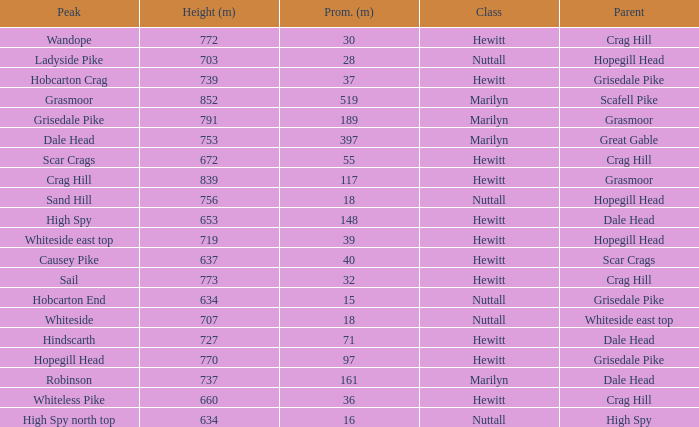Which Parent has height smaller than 756 and a Prom of 39? Hopegill Head. 